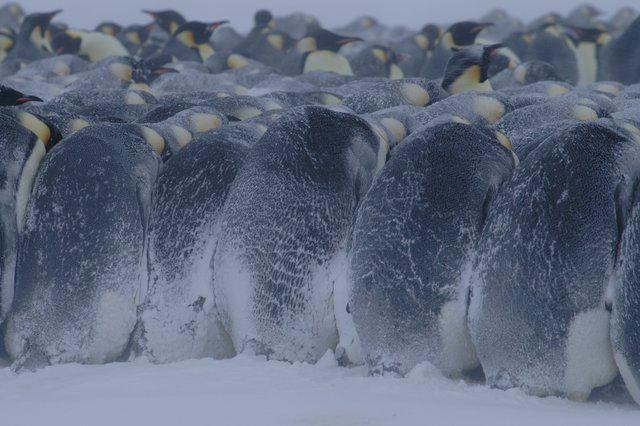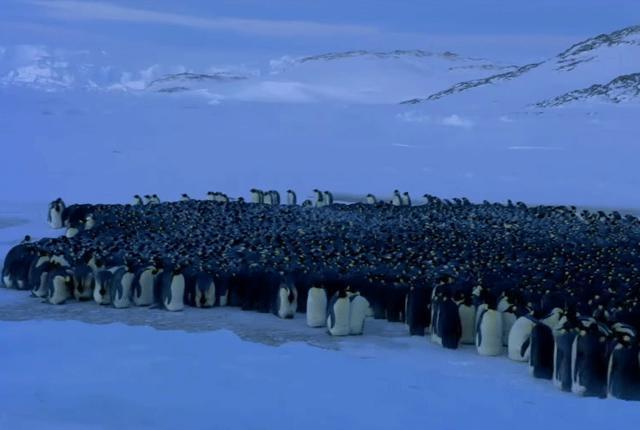The first image is the image on the left, the second image is the image on the right. Given the left and right images, does the statement "In one image the penguins are all huddled together and there is snow on the backs of the outermost penguins." hold true? Answer yes or no. Yes. 